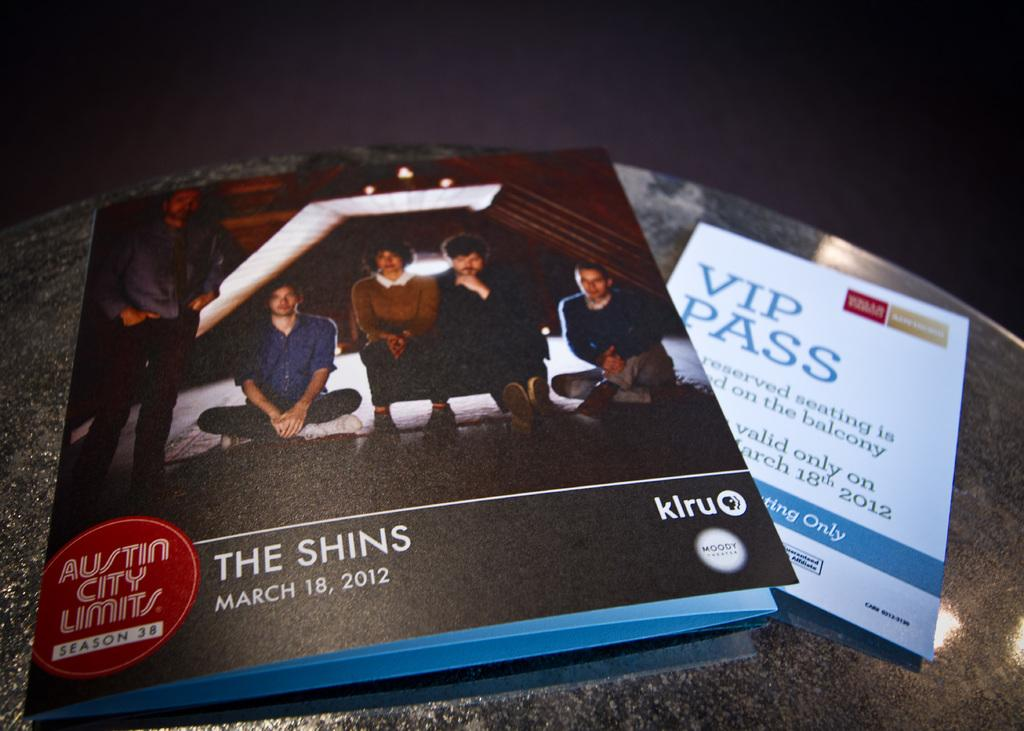What is the main object in the image? There is a table in the image. What is placed on the table? There are two cards on the table. Can you describe the cards? One card has the number "5" and some text on it, while the other card has some text on it. How many spiders are crawling on the cards in the image? There are no spiders present in the image; it only features two cards on a table. What type of sign is visible on the table in the image? There is no sign visible on the table in the image; it only features two cards. 